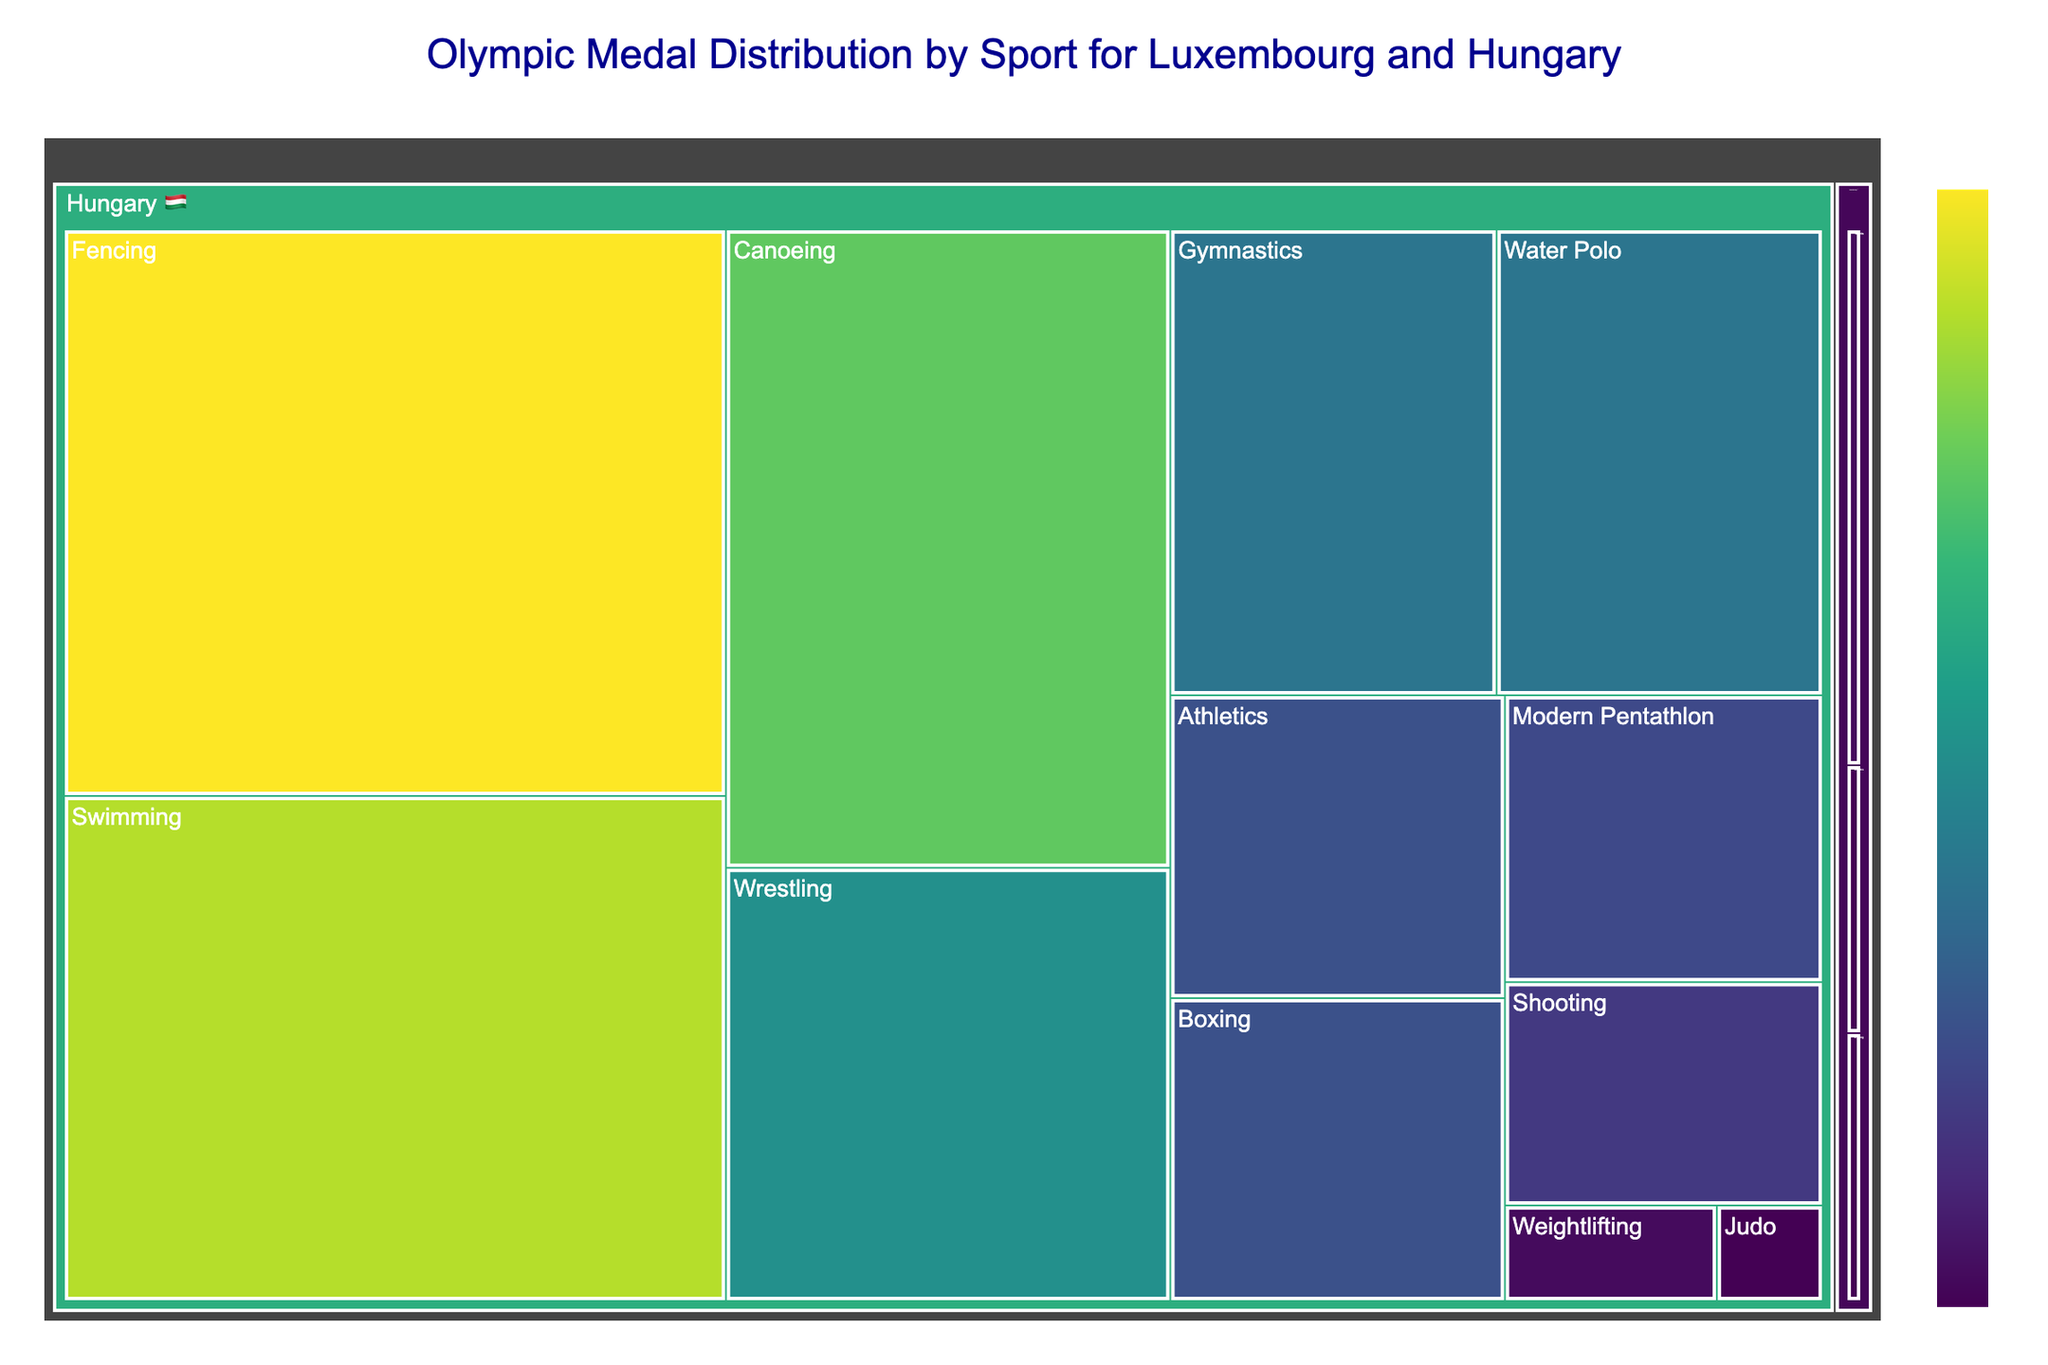What country has the most medals in a single sport according to the figure? The figure shows Hungary has the most number of medals in Fencing with 37.
Answer: Hungary Which country has more sports with medal counts? The figure shows that Hungary has medals in more sports compared to Luxembourg.
Answer: Hungary What is the total number of medals won by Luxembourg? Luxembourg won medals in Tennis (2), Athletics (1), and Cycling (1) – total is 2+1+1.
Answer: 4 How many medals has Hungary won in Water Polo compared to Gymnastics? Hungary won 15 medals in Water Polo and 15 in Gymnastics. This is a direct comparison.
Answer: Equal How does the medal count in Swimming for Hungary compare to Fencing? According to the figure, Hungary won 33 medals in Swimming and 37 in Fencing. 37 is greater than 33.
Answer: Fencing has more Which sport has the least medals for Hungary? Judo has the least medals for Hungary with just 1 medal.
Answer: Judo Sum the medals won by Hungary in Swimming and Canoeing. Hungary won 33 medals in Swimming and 28 in Canoeing. The sum is 33 + 28.
Answer: 61 Which sports have yielded only one medal for Luxembourg? The figure shows Luxembourg won only one medal in Athletics and Cycling.
Answer: Athletics and Cycling What are the sports where Hungary has double-digit medal counts? Hungary has double-digit medals in Swimming, Canoeing, Fencing, Wrestling, Athletics, Water Polo, Gymnastics, and Boxing, according to the figure.
Answer: Swimming, Canoeing, Fencing, Wrestling, Athletics, Water Polo, Gymnastics, Boxing Based on medal values, what is the average medals per sport for Hungary? Hungary's total medals sum is 176 (adding all sports listed) and there are 12 sports. The average is 176/12.
Answer: 14.67 